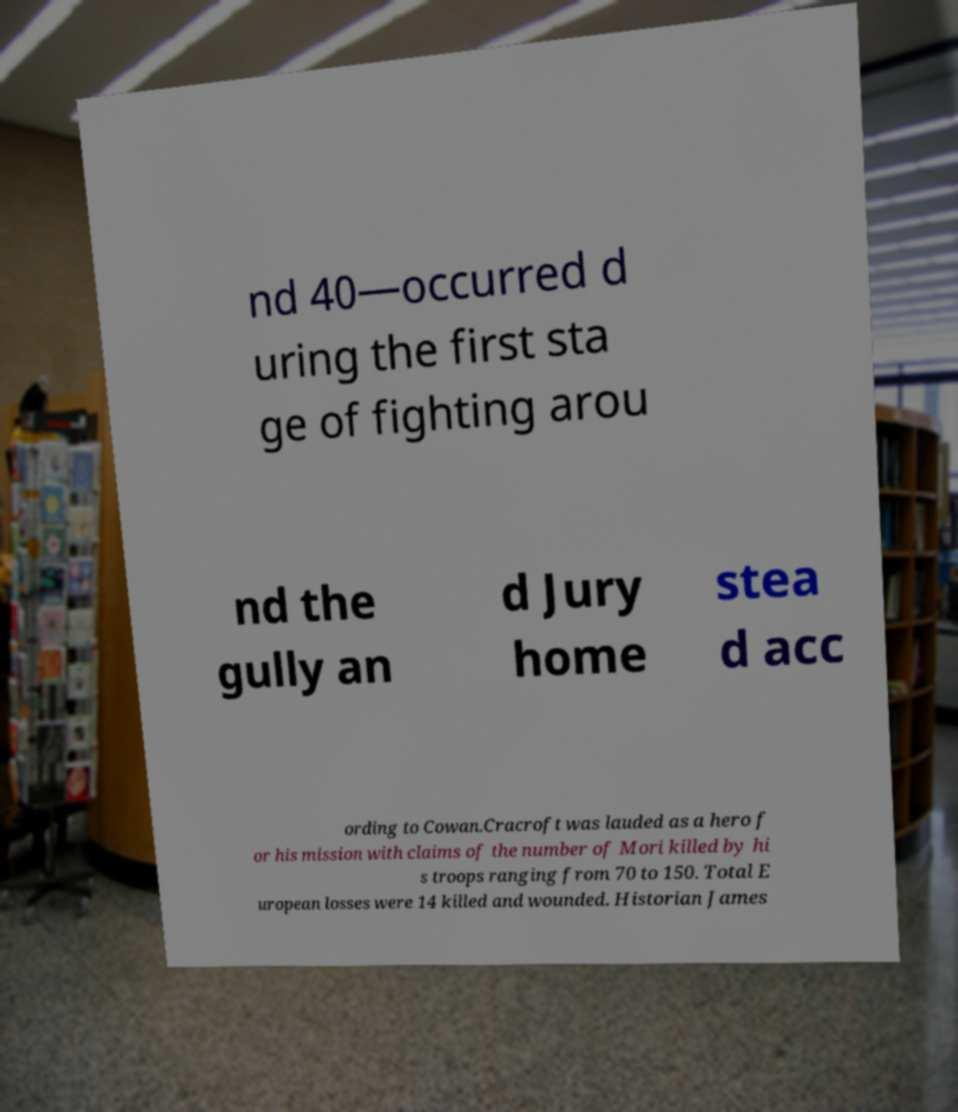What messages or text are displayed in this image? I need them in a readable, typed format. nd 40—occurred d uring the first sta ge of fighting arou nd the gully an d Jury home stea d acc ording to Cowan.Cracroft was lauded as a hero f or his mission with claims of the number of Mori killed by hi s troops ranging from 70 to 150. Total E uropean losses were 14 killed and wounded. Historian James 